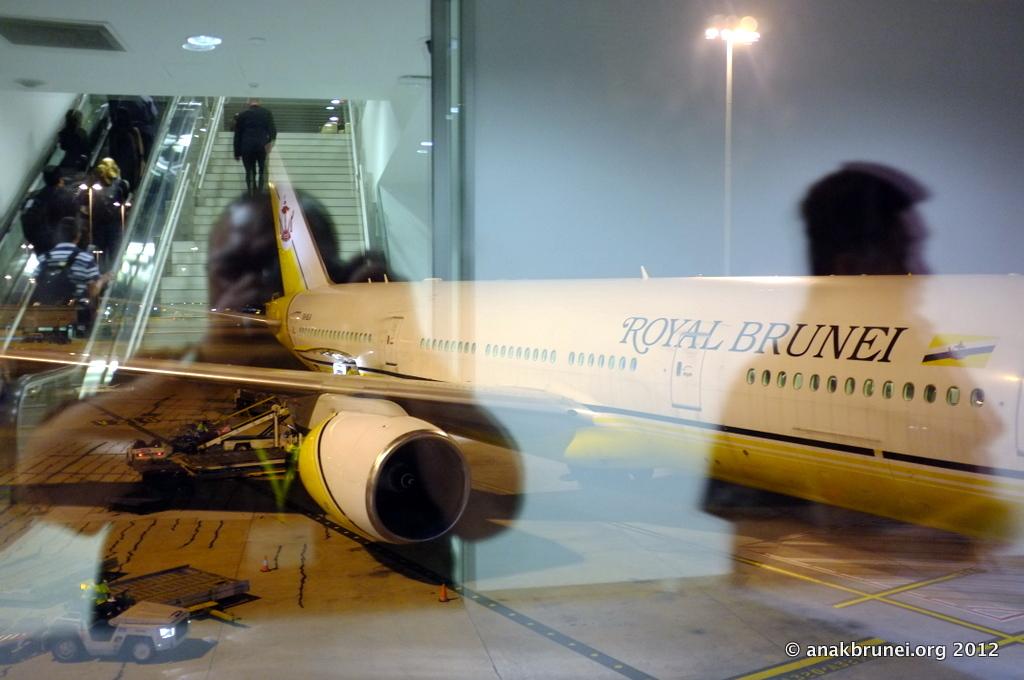What's the name of the airline?
Provide a short and direct response. Royal brunei. What is the website on the image?
Provide a short and direct response. Anakbrunei.org. 